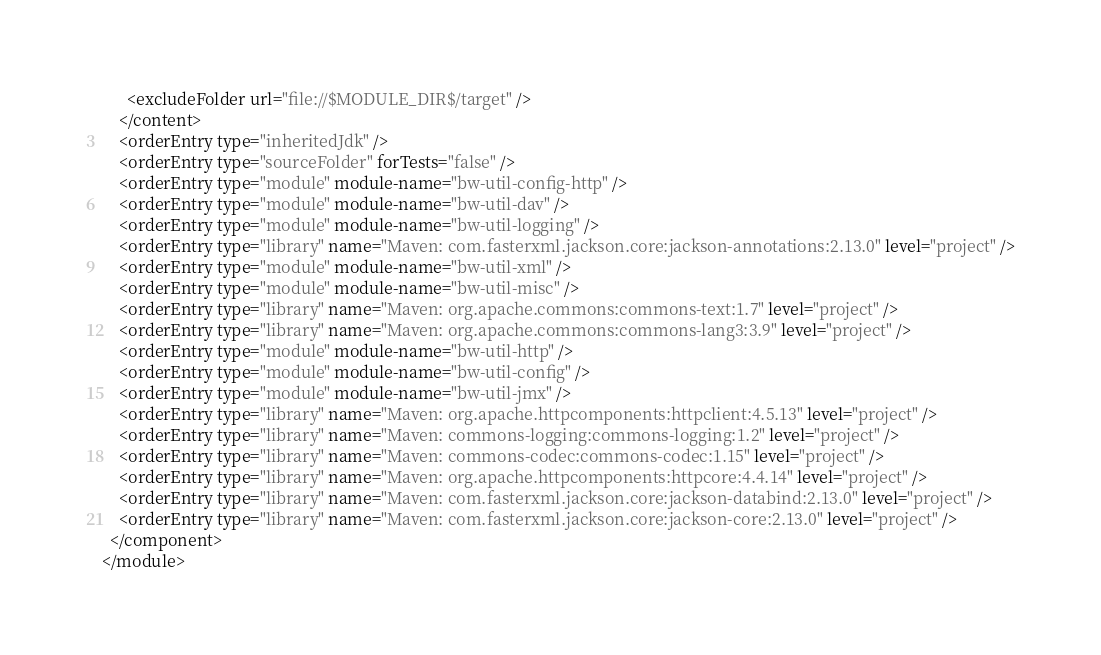Convert code to text. <code><loc_0><loc_0><loc_500><loc_500><_XML_>      <excludeFolder url="file://$MODULE_DIR$/target" />
    </content>
    <orderEntry type="inheritedJdk" />
    <orderEntry type="sourceFolder" forTests="false" />
    <orderEntry type="module" module-name="bw-util-config-http" />
    <orderEntry type="module" module-name="bw-util-dav" />
    <orderEntry type="module" module-name="bw-util-logging" />
    <orderEntry type="library" name="Maven: com.fasterxml.jackson.core:jackson-annotations:2.13.0" level="project" />
    <orderEntry type="module" module-name="bw-util-xml" />
    <orderEntry type="module" module-name="bw-util-misc" />
    <orderEntry type="library" name="Maven: org.apache.commons:commons-text:1.7" level="project" />
    <orderEntry type="library" name="Maven: org.apache.commons:commons-lang3:3.9" level="project" />
    <orderEntry type="module" module-name="bw-util-http" />
    <orderEntry type="module" module-name="bw-util-config" />
    <orderEntry type="module" module-name="bw-util-jmx" />
    <orderEntry type="library" name="Maven: org.apache.httpcomponents:httpclient:4.5.13" level="project" />
    <orderEntry type="library" name="Maven: commons-logging:commons-logging:1.2" level="project" />
    <orderEntry type="library" name="Maven: commons-codec:commons-codec:1.15" level="project" />
    <orderEntry type="library" name="Maven: org.apache.httpcomponents:httpcore:4.4.14" level="project" />
    <orderEntry type="library" name="Maven: com.fasterxml.jackson.core:jackson-databind:2.13.0" level="project" />
    <orderEntry type="library" name="Maven: com.fasterxml.jackson.core:jackson-core:2.13.0" level="project" />
  </component>
</module></code> 